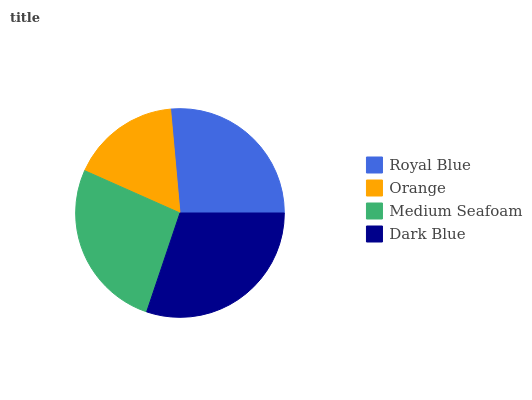Is Orange the minimum?
Answer yes or no. Yes. Is Dark Blue the maximum?
Answer yes or no. Yes. Is Medium Seafoam the minimum?
Answer yes or no. No. Is Medium Seafoam the maximum?
Answer yes or no. No. Is Medium Seafoam greater than Orange?
Answer yes or no. Yes. Is Orange less than Medium Seafoam?
Answer yes or no. Yes. Is Orange greater than Medium Seafoam?
Answer yes or no. No. Is Medium Seafoam less than Orange?
Answer yes or no. No. Is Medium Seafoam the high median?
Answer yes or no. Yes. Is Royal Blue the low median?
Answer yes or no. Yes. Is Royal Blue the high median?
Answer yes or no. No. Is Orange the low median?
Answer yes or no. No. 